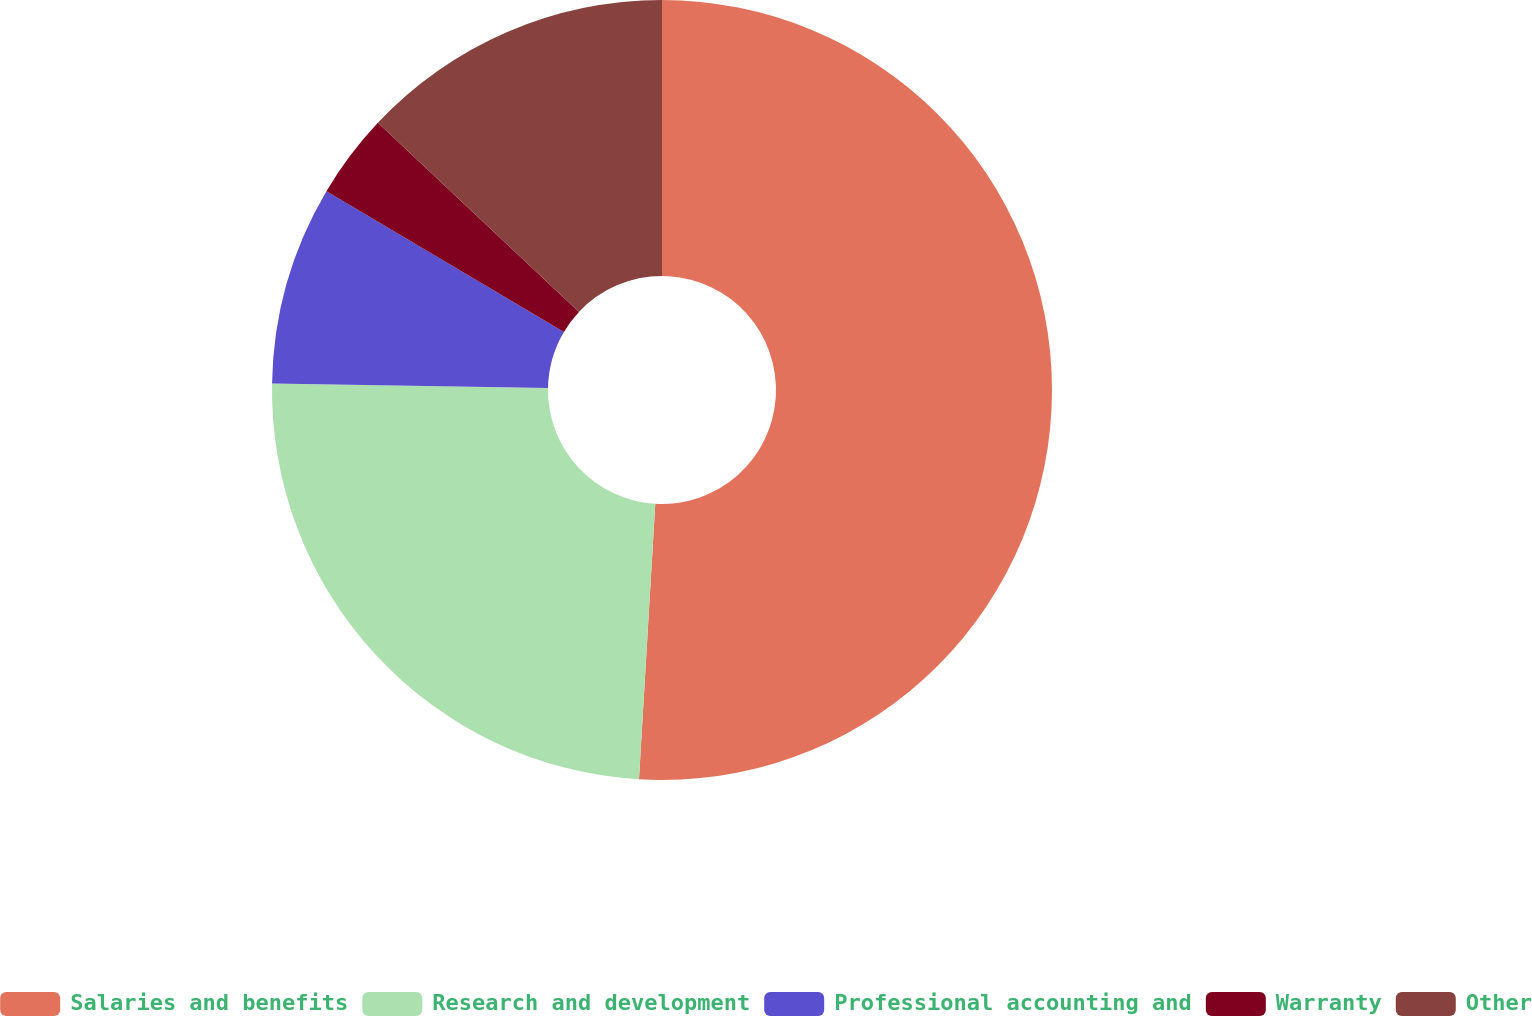<chart> <loc_0><loc_0><loc_500><loc_500><pie_chart><fcel>Salaries and benefits<fcel>Research and development<fcel>Professional accounting and<fcel>Warranty<fcel>Other<nl><fcel>50.94%<fcel>24.33%<fcel>8.24%<fcel>3.5%<fcel>12.99%<nl></chart> 